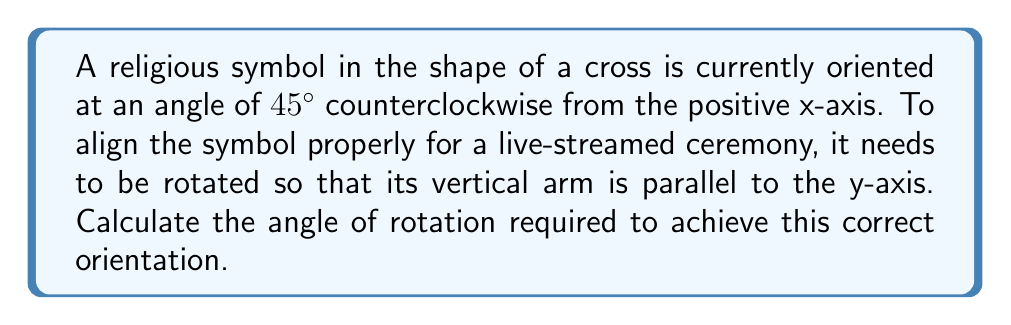Give your solution to this math problem. To solve this problem, we need to follow these steps:

1) The current orientation of the cross is $45°$ counterclockwise from the positive x-axis.

2) For the cross to be properly oriented, its vertical arm should be parallel to the y-axis, which is at $90°$ counterclockwise from the positive x-axis.

3) To find the required rotation angle, we need to calculate the difference between the desired orientation and the current orientation:

   $$\text{Rotation Angle} = \text{Desired Orientation} - \text{Current Orientation}$$

4) Substituting the values:

   $$\text{Rotation Angle} = 90° - 45° = 45°$$

5) Therefore, the cross needs to be rotated $45°$ counterclockwise to achieve the correct orientation.

[asy]
import geometry;

size(200);
draw((-2,0)--(2,0),arrow=Arrow(TeXHead));
draw((0,-2)--(0,2),arrow=Arrow(TeXHead));

draw((1,1)--(-1,-1),linewidth(2));
draw((-1,1)--(1,-1),linewidth(2));

label("45°", (0.5,0.5), NE);
label("Current orientation", (1.5,1.5), E);

draw((0,1.5)--(0,-1.5),linewidth(2)+dashed);
draw((-1.5,0)--(1.5,0),linewidth(2)+dashed);

label("Desired orientation", (1.5,0), E);

draw(arc((0,0),0.7,0,45),arrow=Arrow(TeXHead));
label("45°", (0.4,0.2), NE);
[/asy]
Answer: $45°$ counterclockwise 